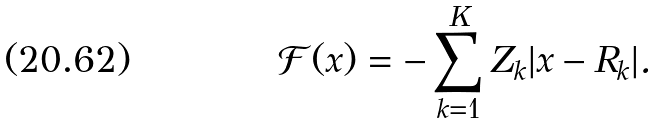<formula> <loc_0><loc_0><loc_500><loc_500>\mathcal { F } ( x ) = - \sum _ { k = 1 } ^ { K } Z _ { k } | x - R _ { k } | .</formula> 